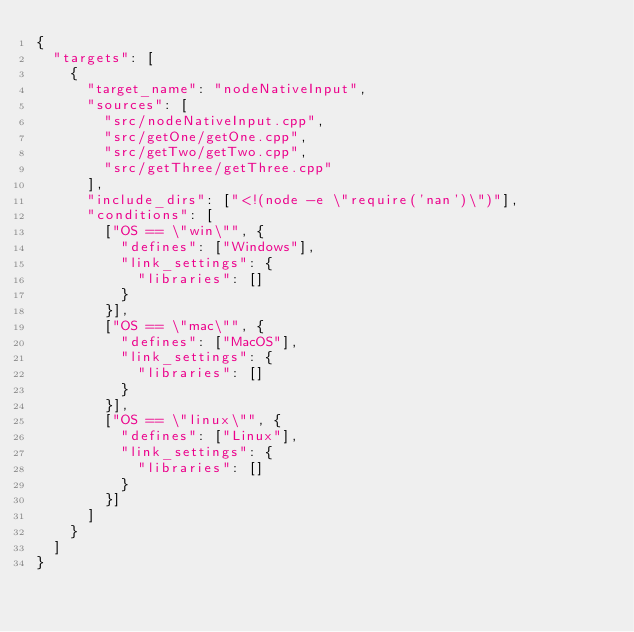Convert code to text. <code><loc_0><loc_0><loc_500><loc_500><_Python_>{
  "targets": [
    {
      "target_name": "nodeNativeInput",
      "sources": [
        "src/nodeNativeInput.cpp",
        "src/getOne/getOne.cpp",
        "src/getTwo/getTwo.cpp",
        "src/getThree/getThree.cpp"
      ],
      "include_dirs": ["<!(node -e \"require('nan')\")"],
      "conditions": [
        ["OS == \"win\"", {
          "defines": ["Windows"],
          "link_settings": {
            "libraries": []
          }
        }],
        ["OS == \"mac\"", {
          "defines": ["MacOS"],
          "link_settings": {
            "libraries": []
          }
        }],
        ["OS == \"linux\"", {
          "defines": ["Linux"],
          "link_settings": {
            "libraries": []
          }
        }]
      ]
    }
  ]
}
</code> 